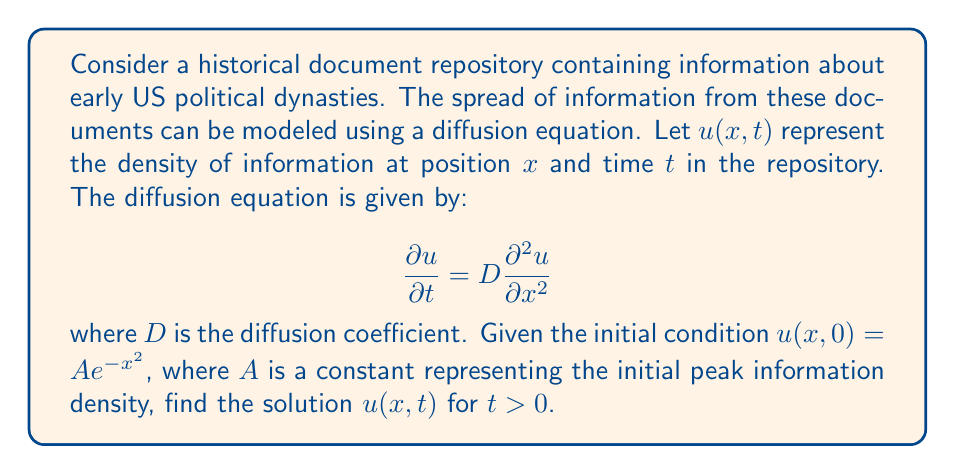Teach me how to tackle this problem. To solve this first-order partial differential equation, we can use the method of separation of variables:

1) Assume a solution of the form $u(x,t) = X(x)T(t)$.

2) Substitute this into the diffusion equation:
   $$X(x)\frac{dT}{dt} = DT(t)\frac{d^2X}{dx^2}$$

3) Divide both sides by $DX(x)T(t)$:
   $$\frac{1}{DT}\frac{dT}{dt} = \frac{1}{X}\frac{d^2X}{dx^2}$$

4) Since the left side depends only on $t$ and the right side only on $x$, both must equal a constant, say $-k^2$:
   $$\frac{1}{T}\frac{dT}{dt} = -Dk^2 \quad \text{and} \quad \frac{1}{X}\frac{d^2X}{dx^2} = -k^2$$

5) Solve these ordinary differential equations:
   $T(t) = Ce^{-Dk^2t}$ and $X(x) = B\cos(kx) + E\sin(kx)$

6) The general solution is:
   $$u(x,t) = \int_0^\infty [a(k)\cos(kx) + b(k)\sin(kx)]e^{-Dk^2t}dk$$

7) Apply the initial condition $u(x,0) = Ae^{-x^2}$:
   $$Ae^{-x^2} = \int_0^\infty [a(k)\cos(kx) + b(k)\sin(kx)]dk$$

8) This is a Fourier cosine transform. The solution is:
   $$a(k) = \frac{A}{2}\sqrt{\frac{\pi}{2}}e^{-k^2/4} \quad \text{and} \quad b(k) = 0$$

9) Substitute back into the general solution:
   $$u(x,t) = \frac{A}{2}\sqrt{\frac{\pi}{2}}\int_0^\infty e^{-k^2/4}\cos(kx)e^{-Dk^2t}dk$$

10) This integral can be evaluated to give the final solution:
    $$u(x,t) = \frac{A}{\sqrt{1+4Dt}}e^{-x^2/(1+4Dt)}$$
Answer: $$u(x,t) = \frac{A}{\sqrt{1+4Dt}}e^{-x^2/(1+4Dt)}$$ 